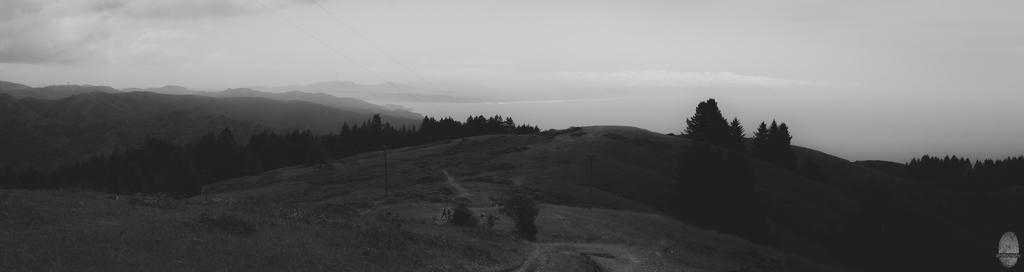What is the color scheme of the image? The image is black and white. What type of vegetation can be seen in the image? There are trees and grass in the image. What structures are present in the image? There are poles in the image. What is the terrain like in the image? There are persons standing on the ground in the image. What can be seen in the background of the image? There are trees, mountains, and clouds in the sky in the background of the image. What type of copper material can be seen on the giraffe in the image? There is no giraffe present in the image, and therefore no copper material can be observed. How many chairs are visible in the image? There are no chairs visible in the image. 